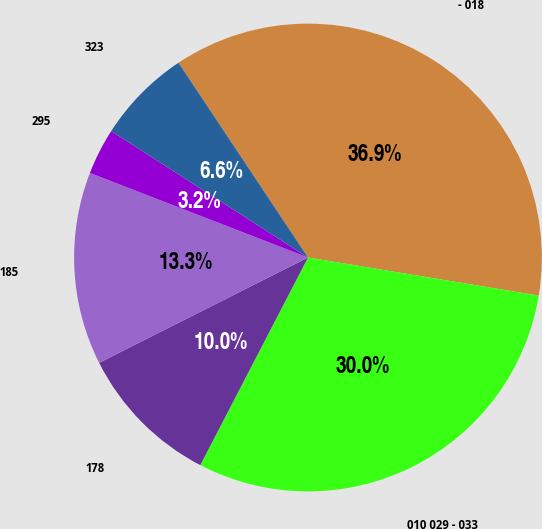<chart> <loc_0><loc_0><loc_500><loc_500><pie_chart><fcel>- 018<fcel>010 029 - 033<fcel>178<fcel>185<fcel>295<fcel>323<nl><fcel>36.94%<fcel>30.01%<fcel>9.95%<fcel>13.32%<fcel>3.2%<fcel>6.57%<nl></chart> 